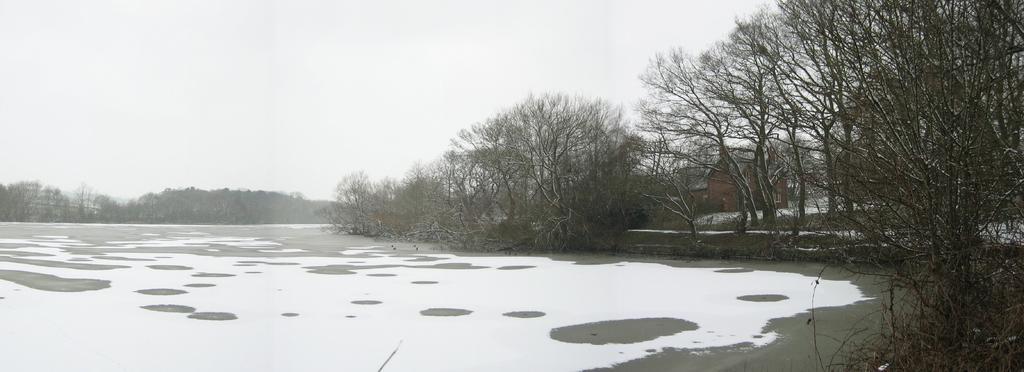How would you summarize this image in a sentence or two? As we can see in the image there are trees, grass, water and in the background there is a house. At the top there is a sky. 